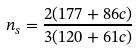<formula> <loc_0><loc_0><loc_500><loc_500>n _ { s } = \frac { 2 ( 1 7 7 + 8 6 c ) } { 3 ( 1 2 0 + 6 1 c ) }</formula> 